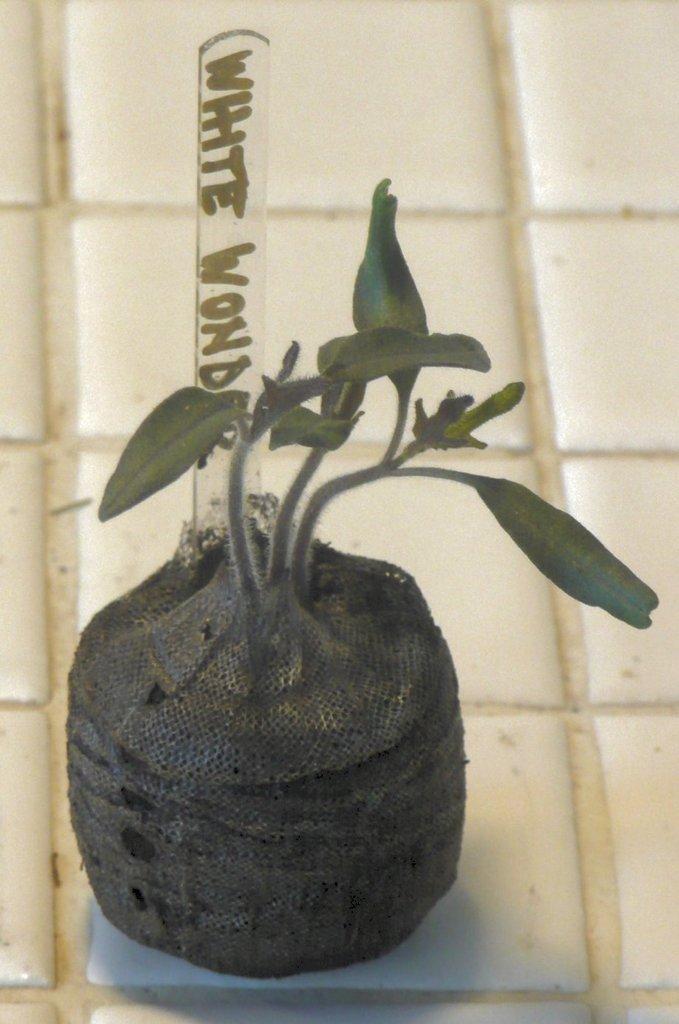Could you give a brief overview of what you see in this image? In this image we can see a plant with name board placed on the floor. 